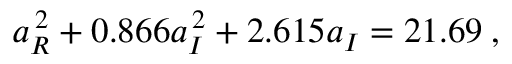<formula> <loc_0><loc_0><loc_500><loc_500>a _ { R } ^ { \, 2 } + 0 . 8 6 6 a _ { I } ^ { \, 2 } + 2 . 6 1 5 a _ { I } = 2 1 . 6 9 \, ,</formula> 